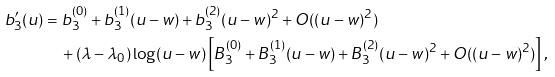Convert formula to latex. <formula><loc_0><loc_0><loc_500><loc_500>b _ { 3 } ^ { \prime } ( u ) & = b _ { 3 } ^ { ( 0 ) } + b _ { 3 } ^ { ( 1 ) } ( u - w ) + b _ { 3 } ^ { ( 2 ) } ( u - w ) ^ { 2 } + O ( ( u - w ) ^ { 2 } ) \\ & \quad + ( \lambda - \lambda _ { 0 } ) \log ( u - w ) \left [ B _ { 3 } ^ { ( 0 ) } + B _ { 3 } ^ { ( 1 ) } ( u - w ) + B _ { 3 } ^ { ( 2 ) } ( u - w ) ^ { 2 } + O ( ( u - w ) ^ { 2 } ) \right ] ,</formula> 